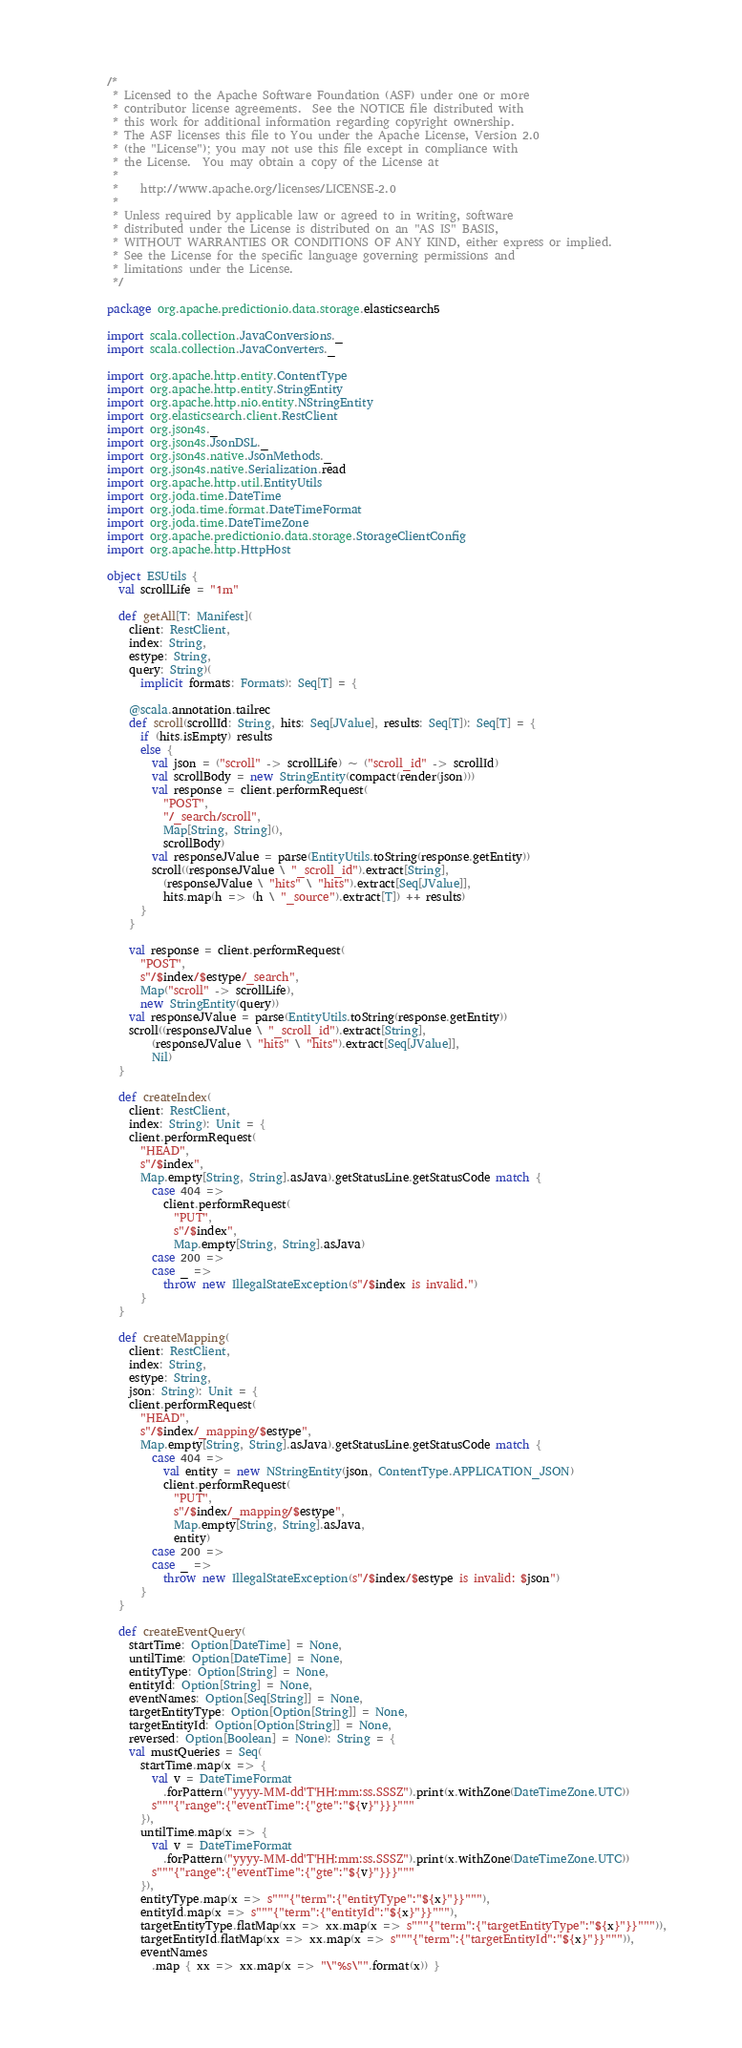Convert code to text. <code><loc_0><loc_0><loc_500><loc_500><_Scala_>/*
 * Licensed to the Apache Software Foundation (ASF) under one or more
 * contributor license agreements.  See the NOTICE file distributed with
 * this work for additional information regarding copyright ownership.
 * The ASF licenses this file to You under the Apache License, Version 2.0
 * (the "License"); you may not use this file except in compliance with
 * the License.  You may obtain a copy of the License at
 *
 *    http://www.apache.org/licenses/LICENSE-2.0
 *
 * Unless required by applicable law or agreed to in writing, software
 * distributed under the License is distributed on an "AS IS" BASIS,
 * WITHOUT WARRANTIES OR CONDITIONS OF ANY KIND, either express or implied.
 * See the License for the specific language governing permissions and
 * limitations under the License.
 */

package org.apache.predictionio.data.storage.elasticsearch5

import scala.collection.JavaConversions._
import scala.collection.JavaConverters._

import org.apache.http.entity.ContentType
import org.apache.http.entity.StringEntity
import org.apache.http.nio.entity.NStringEntity
import org.elasticsearch.client.RestClient
import org.json4s._
import org.json4s.JsonDSL._
import org.json4s.native.JsonMethods._
import org.json4s.native.Serialization.read
import org.apache.http.util.EntityUtils
import org.joda.time.DateTime
import org.joda.time.format.DateTimeFormat
import org.joda.time.DateTimeZone
import org.apache.predictionio.data.storage.StorageClientConfig
import org.apache.http.HttpHost

object ESUtils {
  val scrollLife = "1m"

  def getAll[T: Manifest](
    client: RestClient,
    index: String,
    estype: String,
    query: String)(
      implicit formats: Formats): Seq[T] = {

    @scala.annotation.tailrec
    def scroll(scrollId: String, hits: Seq[JValue], results: Seq[T]): Seq[T] = {
      if (hits.isEmpty) results
      else {
        val json = ("scroll" -> scrollLife) ~ ("scroll_id" -> scrollId)
        val scrollBody = new StringEntity(compact(render(json)))
        val response = client.performRequest(
          "POST",
          "/_search/scroll",
          Map[String, String](),
          scrollBody)
        val responseJValue = parse(EntityUtils.toString(response.getEntity))
        scroll((responseJValue \ "_scroll_id").extract[String],
          (responseJValue \ "hits" \ "hits").extract[Seq[JValue]],
          hits.map(h => (h \ "_source").extract[T]) ++ results)
      }
    }

    val response = client.performRequest(
      "POST",
      s"/$index/$estype/_search",
      Map("scroll" -> scrollLife),
      new StringEntity(query))
    val responseJValue = parse(EntityUtils.toString(response.getEntity))
    scroll((responseJValue \ "_scroll_id").extract[String],
        (responseJValue \ "hits" \ "hits").extract[Seq[JValue]],
        Nil)
  }

  def createIndex(
    client: RestClient,
    index: String): Unit = {
    client.performRequest(
      "HEAD",
      s"/$index",
      Map.empty[String, String].asJava).getStatusLine.getStatusCode match {
        case 404 =>
          client.performRequest(
            "PUT",
            s"/$index",
            Map.empty[String, String].asJava)
        case 200 =>
        case _ =>
          throw new IllegalStateException(s"/$index is invalid.")
      }
  }

  def createMapping(
    client: RestClient,
    index: String,
    estype: String,
    json: String): Unit = {
    client.performRequest(
      "HEAD",
      s"/$index/_mapping/$estype",
      Map.empty[String, String].asJava).getStatusLine.getStatusCode match {
        case 404 =>
          val entity = new NStringEntity(json, ContentType.APPLICATION_JSON)
          client.performRequest(
            "PUT",
            s"/$index/_mapping/$estype",
            Map.empty[String, String].asJava,
            entity)
        case 200 =>
        case _ =>
          throw new IllegalStateException(s"/$index/$estype is invalid: $json")
      }
  }

  def createEventQuery(
    startTime: Option[DateTime] = None,
    untilTime: Option[DateTime] = None,
    entityType: Option[String] = None,
    entityId: Option[String] = None,
    eventNames: Option[Seq[String]] = None,
    targetEntityType: Option[Option[String]] = None,
    targetEntityId: Option[Option[String]] = None,
    reversed: Option[Boolean] = None): String = {
    val mustQueries = Seq(
      startTime.map(x => {
        val v = DateTimeFormat
          .forPattern("yyyy-MM-dd'T'HH:mm:ss.SSSZ").print(x.withZone(DateTimeZone.UTC))
        s"""{"range":{"eventTime":{"gte":"${v}"}}}"""
      }),
      untilTime.map(x => {
        val v = DateTimeFormat
          .forPattern("yyyy-MM-dd'T'HH:mm:ss.SSSZ").print(x.withZone(DateTimeZone.UTC))
        s"""{"range":{"eventTime":{"gte":"${v}"}}}"""
      }),
      entityType.map(x => s"""{"term":{"entityType":"${x}"}}"""),
      entityId.map(x => s"""{"term":{"entityId":"${x}"}}"""),
      targetEntityType.flatMap(xx => xx.map(x => s"""{"term":{"targetEntityType":"${x}"}}""")),
      targetEntityId.flatMap(xx => xx.map(x => s"""{"term":{"targetEntityId":"${x}"}}""")),
      eventNames
        .map { xx => xx.map(x => "\"%s\"".format(x)) }</code> 